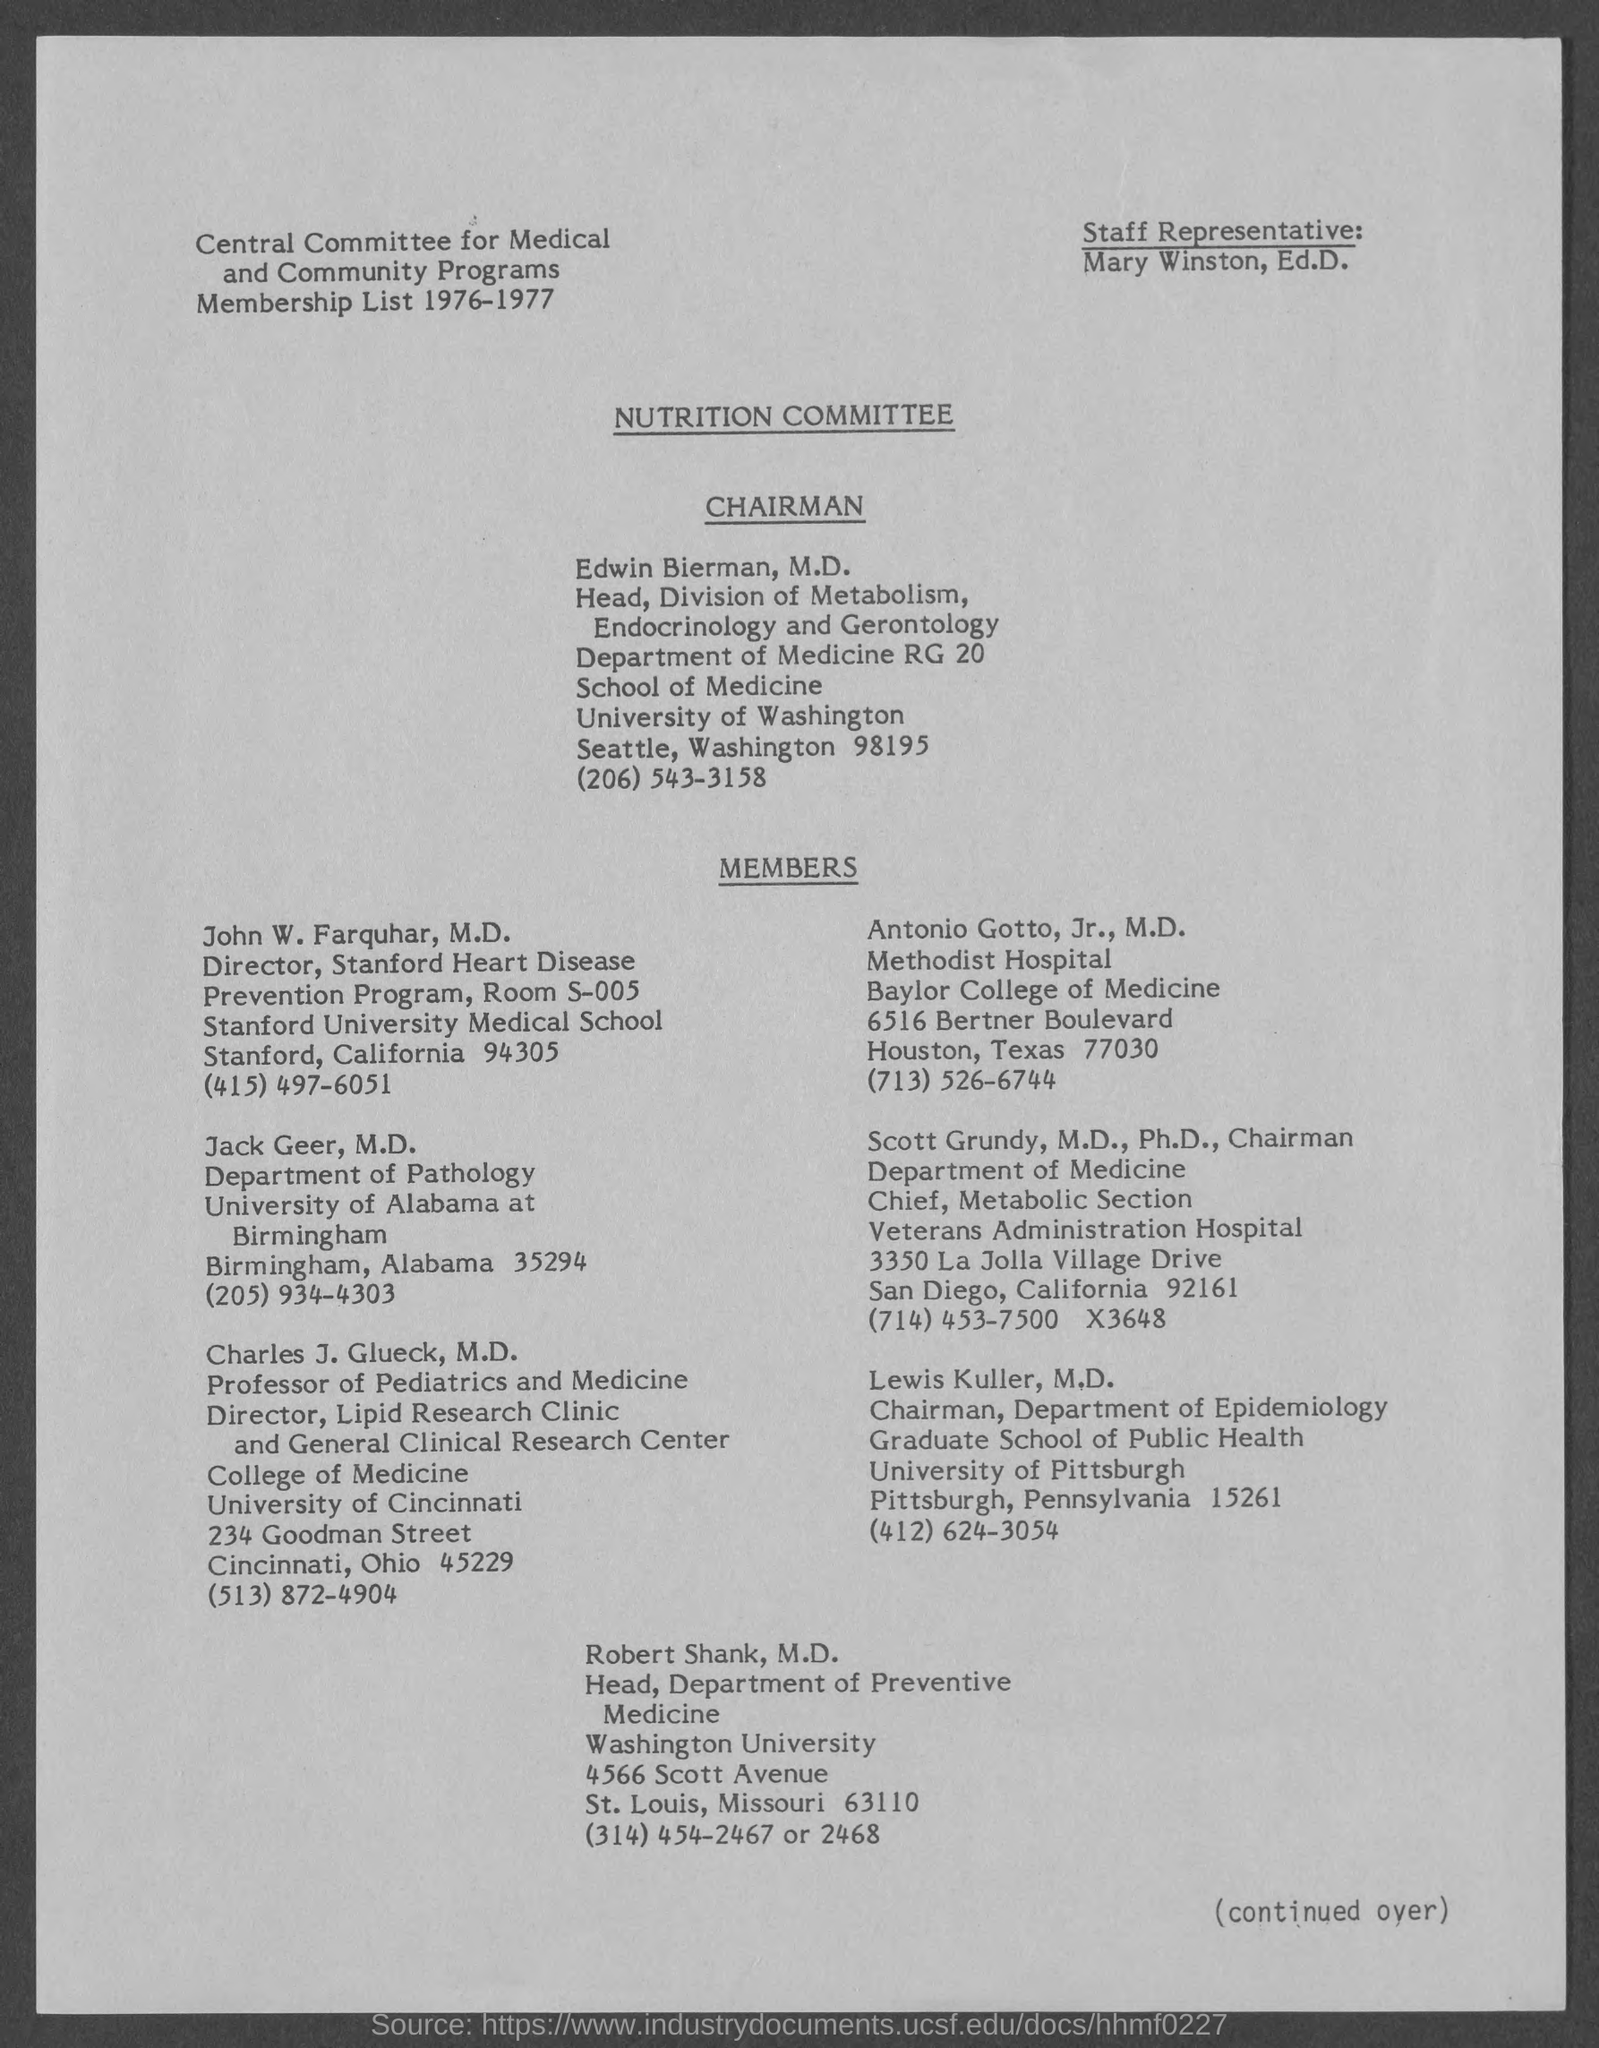Who is the Staff Representative?
Keep it short and to the point. Mary Winston. Who is the chairman of the NUTRITION COMMITTEE?
Your answer should be compact. Edwin Bierman, M.D. For which year is the membership list?
Keep it short and to the point. 1976-1977. What is the telephone number of John W. Farquhar, M.D.?
Your answer should be compact. (415) 497-6051. Which department is Jack Geer part of?
Your response must be concise. Pathology. Which university is Lewis Kuller part of?
Offer a very short reply. University of Pittsburgh. Who is the Professor of Pediatrics and Medicine?
Your answer should be compact. Charles J. Glueck, M.D. 